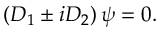<formula> <loc_0><loc_0><loc_500><loc_500>\left ( D _ { 1 } \pm i D _ { 2 } \right ) \psi = 0 .</formula> 